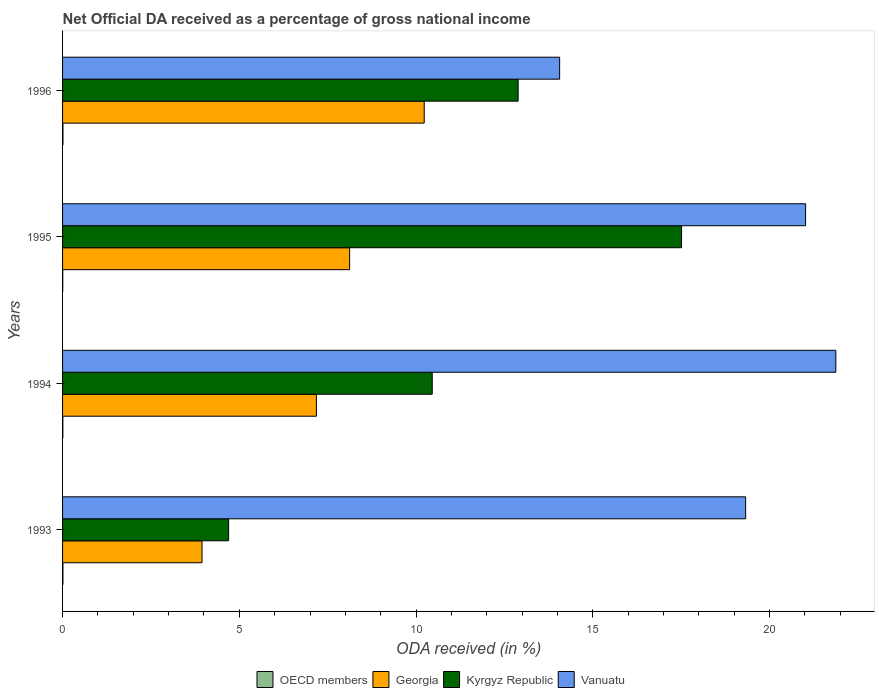How many different coloured bars are there?
Your answer should be very brief. 4. How many bars are there on the 2nd tick from the top?
Keep it short and to the point. 4. How many bars are there on the 1st tick from the bottom?
Provide a succinct answer. 4. What is the net official DA received in Vanuatu in 1995?
Your answer should be very brief. 21.02. Across all years, what is the maximum net official DA received in Kyrgyz Republic?
Provide a succinct answer. 17.51. Across all years, what is the minimum net official DA received in Kyrgyz Republic?
Offer a terse response. 4.7. What is the total net official DA received in Kyrgyz Republic in the graph?
Your answer should be very brief. 45.55. What is the difference between the net official DA received in Georgia in 1994 and that in 1996?
Your answer should be very brief. -3.05. What is the difference between the net official DA received in Kyrgyz Republic in 1993 and the net official DA received in Vanuatu in 1995?
Ensure brevity in your answer.  -16.32. What is the average net official DA received in OECD members per year?
Give a very brief answer. 0.01. In the year 1996, what is the difference between the net official DA received in Georgia and net official DA received in OECD members?
Ensure brevity in your answer.  10.22. What is the ratio of the net official DA received in OECD members in 1994 to that in 1996?
Your answer should be very brief. 0.74. Is the difference between the net official DA received in Georgia in 1993 and 1994 greater than the difference between the net official DA received in OECD members in 1993 and 1994?
Make the answer very short. No. What is the difference between the highest and the second highest net official DA received in Kyrgyz Republic?
Your response must be concise. 4.62. What is the difference between the highest and the lowest net official DA received in Georgia?
Ensure brevity in your answer.  6.29. In how many years, is the net official DA received in Kyrgyz Republic greater than the average net official DA received in Kyrgyz Republic taken over all years?
Make the answer very short. 2. Is the sum of the net official DA received in OECD members in 1993 and 1995 greater than the maximum net official DA received in Georgia across all years?
Provide a succinct answer. No. What does the 3rd bar from the bottom in 1996 represents?
Offer a very short reply. Kyrgyz Republic. Is it the case that in every year, the sum of the net official DA received in OECD members and net official DA received in Georgia is greater than the net official DA received in Kyrgyz Republic?
Provide a short and direct response. No. How many bars are there?
Offer a very short reply. 16. Are the values on the major ticks of X-axis written in scientific E-notation?
Give a very brief answer. No. Does the graph contain any zero values?
Your answer should be very brief. No. Where does the legend appear in the graph?
Ensure brevity in your answer.  Bottom center. What is the title of the graph?
Your answer should be very brief. Net Official DA received as a percentage of gross national income. Does "Latin America(all income levels)" appear as one of the legend labels in the graph?
Give a very brief answer. No. What is the label or title of the X-axis?
Provide a short and direct response. ODA received (in %). What is the ODA received (in %) of OECD members in 1993?
Ensure brevity in your answer.  0.01. What is the ODA received (in %) in Georgia in 1993?
Your answer should be very brief. 3.95. What is the ODA received (in %) in Kyrgyz Republic in 1993?
Give a very brief answer. 4.7. What is the ODA received (in %) of Vanuatu in 1993?
Offer a terse response. 19.32. What is the ODA received (in %) of OECD members in 1994?
Ensure brevity in your answer.  0.01. What is the ODA received (in %) in Georgia in 1994?
Your response must be concise. 7.18. What is the ODA received (in %) in Kyrgyz Republic in 1994?
Make the answer very short. 10.46. What is the ODA received (in %) of Vanuatu in 1994?
Ensure brevity in your answer.  21.88. What is the ODA received (in %) in OECD members in 1995?
Ensure brevity in your answer.  0.01. What is the ODA received (in %) of Georgia in 1995?
Provide a succinct answer. 8.12. What is the ODA received (in %) in Kyrgyz Republic in 1995?
Make the answer very short. 17.51. What is the ODA received (in %) of Vanuatu in 1995?
Give a very brief answer. 21.02. What is the ODA received (in %) of OECD members in 1996?
Your answer should be compact. 0.01. What is the ODA received (in %) in Georgia in 1996?
Your answer should be compact. 10.23. What is the ODA received (in %) in Kyrgyz Republic in 1996?
Offer a terse response. 12.89. What is the ODA received (in %) of Vanuatu in 1996?
Make the answer very short. 14.06. Across all years, what is the maximum ODA received (in %) of OECD members?
Provide a short and direct response. 0.01. Across all years, what is the maximum ODA received (in %) in Georgia?
Provide a succinct answer. 10.23. Across all years, what is the maximum ODA received (in %) of Kyrgyz Republic?
Your answer should be very brief. 17.51. Across all years, what is the maximum ODA received (in %) of Vanuatu?
Your answer should be compact. 21.88. Across all years, what is the minimum ODA received (in %) in OECD members?
Your answer should be compact. 0.01. Across all years, what is the minimum ODA received (in %) in Georgia?
Offer a very short reply. 3.95. Across all years, what is the minimum ODA received (in %) in Kyrgyz Republic?
Ensure brevity in your answer.  4.7. Across all years, what is the minimum ODA received (in %) in Vanuatu?
Your answer should be very brief. 14.06. What is the total ODA received (in %) of OECD members in the graph?
Offer a terse response. 0.04. What is the total ODA received (in %) of Georgia in the graph?
Your answer should be very brief. 29.48. What is the total ODA received (in %) of Kyrgyz Republic in the graph?
Your response must be concise. 45.55. What is the total ODA received (in %) of Vanuatu in the graph?
Your answer should be very brief. 76.28. What is the difference between the ODA received (in %) in OECD members in 1993 and that in 1994?
Offer a terse response. 0. What is the difference between the ODA received (in %) of Georgia in 1993 and that in 1994?
Give a very brief answer. -3.24. What is the difference between the ODA received (in %) in Kyrgyz Republic in 1993 and that in 1994?
Provide a succinct answer. -5.76. What is the difference between the ODA received (in %) of Vanuatu in 1993 and that in 1994?
Your response must be concise. -2.55. What is the difference between the ODA received (in %) of OECD members in 1993 and that in 1995?
Your answer should be compact. 0.01. What is the difference between the ODA received (in %) of Georgia in 1993 and that in 1995?
Ensure brevity in your answer.  -4.18. What is the difference between the ODA received (in %) in Kyrgyz Republic in 1993 and that in 1995?
Your answer should be compact. -12.81. What is the difference between the ODA received (in %) of Vanuatu in 1993 and that in 1995?
Give a very brief answer. -1.7. What is the difference between the ODA received (in %) in OECD members in 1993 and that in 1996?
Keep it short and to the point. -0. What is the difference between the ODA received (in %) of Georgia in 1993 and that in 1996?
Give a very brief answer. -6.29. What is the difference between the ODA received (in %) in Kyrgyz Republic in 1993 and that in 1996?
Your answer should be compact. -8.19. What is the difference between the ODA received (in %) in Vanuatu in 1993 and that in 1996?
Your response must be concise. 5.26. What is the difference between the ODA received (in %) of OECD members in 1994 and that in 1995?
Your response must be concise. 0. What is the difference between the ODA received (in %) of Georgia in 1994 and that in 1995?
Give a very brief answer. -0.94. What is the difference between the ODA received (in %) of Kyrgyz Republic in 1994 and that in 1995?
Your answer should be compact. -7.05. What is the difference between the ODA received (in %) in Vanuatu in 1994 and that in 1995?
Give a very brief answer. 0.86. What is the difference between the ODA received (in %) of OECD members in 1994 and that in 1996?
Make the answer very short. -0. What is the difference between the ODA received (in %) of Georgia in 1994 and that in 1996?
Provide a short and direct response. -3.05. What is the difference between the ODA received (in %) of Kyrgyz Republic in 1994 and that in 1996?
Your answer should be compact. -2.43. What is the difference between the ODA received (in %) in Vanuatu in 1994 and that in 1996?
Your response must be concise. 7.81. What is the difference between the ODA received (in %) in OECD members in 1995 and that in 1996?
Make the answer very short. -0.01. What is the difference between the ODA received (in %) of Georgia in 1995 and that in 1996?
Provide a short and direct response. -2.11. What is the difference between the ODA received (in %) in Kyrgyz Republic in 1995 and that in 1996?
Offer a terse response. 4.62. What is the difference between the ODA received (in %) in Vanuatu in 1995 and that in 1996?
Offer a terse response. 6.96. What is the difference between the ODA received (in %) of OECD members in 1993 and the ODA received (in %) of Georgia in 1994?
Offer a terse response. -7.17. What is the difference between the ODA received (in %) of OECD members in 1993 and the ODA received (in %) of Kyrgyz Republic in 1994?
Make the answer very short. -10.45. What is the difference between the ODA received (in %) of OECD members in 1993 and the ODA received (in %) of Vanuatu in 1994?
Ensure brevity in your answer.  -21.87. What is the difference between the ODA received (in %) in Georgia in 1993 and the ODA received (in %) in Kyrgyz Republic in 1994?
Keep it short and to the point. -6.51. What is the difference between the ODA received (in %) of Georgia in 1993 and the ODA received (in %) of Vanuatu in 1994?
Ensure brevity in your answer.  -17.93. What is the difference between the ODA received (in %) of Kyrgyz Republic in 1993 and the ODA received (in %) of Vanuatu in 1994?
Make the answer very short. -17.18. What is the difference between the ODA received (in %) in OECD members in 1993 and the ODA received (in %) in Georgia in 1995?
Provide a short and direct response. -8.11. What is the difference between the ODA received (in %) of OECD members in 1993 and the ODA received (in %) of Kyrgyz Republic in 1995?
Provide a succinct answer. -17.5. What is the difference between the ODA received (in %) of OECD members in 1993 and the ODA received (in %) of Vanuatu in 1995?
Provide a succinct answer. -21.01. What is the difference between the ODA received (in %) of Georgia in 1993 and the ODA received (in %) of Kyrgyz Republic in 1995?
Ensure brevity in your answer.  -13.57. What is the difference between the ODA received (in %) of Georgia in 1993 and the ODA received (in %) of Vanuatu in 1995?
Your answer should be very brief. -17.07. What is the difference between the ODA received (in %) of Kyrgyz Republic in 1993 and the ODA received (in %) of Vanuatu in 1995?
Offer a terse response. -16.32. What is the difference between the ODA received (in %) in OECD members in 1993 and the ODA received (in %) in Georgia in 1996?
Your answer should be very brief. -10.22. What is the difference between the ODA received (in %) in OECD members in 1993 and the ODA received (in %) in Kyrgyz Republic in 1996?
Your answer should be compact. -12.88. What is the difference between the ODA received (in %) in OECD members in 1993 and the ODA received (in %) in Vanuatu in 1996?
Offer a terse response. -14.05. What is the difference between the ODA received (in %) of Georgia in 1993 and the ODA received (in %) of Kyrgyz Republic in 1996?
Make the answer very short. -8.94. What is the difference between the ODA received (in %) in Georgia in 1993 and the ODA received (in %) in Vanuatu in 1996?
Offer a terse response. -10.12. What is the difference between the ODA received (in %) of Kyrgyz Republic in 1993 and the ODA received (in %) of Vanuatu in 1996?
Offer a very short reply. -9.36. What is the difference between the ODA received (in %) in OECD members in 1994 and the ODA received (in %) in Georgia in 1995?
Ensure brevity in your answer.  -8.11. What is the difference between the ODA received (in %) in OECD members in 1994 and the ODA received (in %) in Kyrgyz Republic in 1995?
Your response must be concise. -17.5. What is the difference between the ODA received (in %) in OECD members in 1994 and the ODA received (in %) in Vanuatu in 1995?
Make the answer very short. -21.01. What is the difference between the ODA received (in %) in Georgia in 1994 and the ODA received (in %) in Kyrgyz Republic in 1995?
Offer a very short reply. -10.33. What is the difference between the ODA received (in %) in Georgia in 1994 and the ODA received (in %) in Vanuatu in 1995?
Make the answer very short. -13.84. What is the difference between the ODA received (in %) in Kyrgyz Republic in 1994 and the ODA received (in %) in Vanuatu in 1995?
Offer a very short reply. -10.56. What is the difference between the ODA received (in %) of OECD members in 1994 and the ODA received (in %) of Georgia in 1996?
Make the answer very short. -10.22. What is the difference between the ODA received (in %) of OECD members in 1994 and the ODA received (in %) of Kyrgyz Republic in 1996?
Keep it short and to the point. -12.88. What is the difference between the ODA received (in %) of OECD members in 1994 and the ODA received (in %) of Vanuatu in 1996?
Provide a short and direct response. -14.05. What is the difference between the ODA received (in %) of Georgia in 1994 and the ODA received (in %) of Kyrgyz Republic in 1996?
Provide a short and direct response. -5.71. What is the difference between the ODA received (in %) of Georgia in 1994 and the ODA received (in %) of Vanuatu in 1996?
Make the answer very short. -6.88. What is the difference between the ODA received (in %) of Kyrgyz Republic in 1994 and the ODA received (in %) of Vanuatu in 1996?
Offer a very short reply. -3.6. What is the difference between the ODA received (in %) in OECD members in 1995 and the ODA received (in %) in Georgia in 1996?
Offer a terse response. -10.23. What is the difference between the ODA received (in %) in OECD members in 1995 and the ODA received (in %) in Kyrgyz Republic in 1996?
Provide a succinct answer. -12.88. What is the difference between the ODA received (in %) in OECD members in 1995 and the ODA received (in %) in Vanuatu in 1996?
Your response must be concise. -14.06. What is the difference between the ODA received (in %) in Georgia in 1995 and the ODA received (in %) in Kyrgyz Republic in 1996?
Your answer should be compact. -4.77. What is the difference between the ODA received (in %) in Georgia in 1995 and the ODA received (in %) in Vanuatu in 1996?
Offer a very short reply. -5.94. What is the difference between the ODA received (in %) of Kyrgyz Republic in 1995 and the ODA received (in %) of Vanuatu in 1996?
Provide a succinct answer. 3.45. What is the average ODA received (in %) in OECD members per year?
Provide a short and direct response. 0.01. What is the average ODA received (in %) of Georgia per year?
Give a very brief answer. 7.37. What is the average ODA received (in %) of Kyrgyz Republic per year?
Offer a very short reply. 11.39. What is the average ODA received (in %) of Vanuatu per year?
Your response must be concise. 19.07. In the year 1993, what is the difference between the ODA received (in %) in OECD members and ODA received (in %) in Georgia?
Provide a succinct answer. -3.94. In the year 1993, what is the difference between the ODA received (in %) of OECD members and ODA received (in %) of Kyrgyz Republic?
Keep it short and to the point. -4.69. In the year 1993, what is the difference between the ODA received (in %) in OECD members and ODA received (in %) in Vanuatu?
Your answer should be compact. -19.31. In the year 1993, what is the difference between the ODA received (in %) of Georgia and ODA received (in %) of Kyrgyz Republic?
Your answer should be very brief. -0.75. In the year 1993, what is the difference between the ODA received (in %) of Georgia and ODA received (in %) of Vanuatu?
Your answer should be very brief. -15.38. In the year 1993, what is the difference between the ODA received (in %) of Kyrgyz Republic and ODA received (in %) of Vanuatu?
Offer a terse response. -14.63. In the year 1994, what is the difference between the ODA received (in %) in OECD members and ODA received (in %) in Georgia?
Give a very brief answer. -7.17. In the year 1994, what is the difference between the ODA received (in %) in OECD members and ODA received (in %) in Kyrgyz Republic?
Make the answer very short. -10.45. In the year 1994, what is the difference between the ODA received (in %) of OECD members and ODA received (in %) of Vanuatu?
Offer a terse response. -21.87. In the year 1994, what is the difference between the ODA received (in %) of Georgia and ODA received (in %) of Kyrgyz Republic?
Provide a short and direct response. -3.28. In the year 1994, what is the difference between the ODA received (in %) in Georgia and ODA received (in %) in Vanuatu?
Provide a succinct answer. -14.69. In the year 1994, what is the difference between the ODA received (in %) of Kyrgyz Republic and ODA received (in %) of Vanuatu?
Give a very brief answer. -11.42. In the year 1995, what is the difference between the ODA received (in %) in OECD members and ODA received (in %) in Georgia?
Your answer should be very brief. -8.12. In the year 1995, what is the difference between the ODA received (in %) in OECD members and ODA received (in %) in Kyrgyz Republic?
Provide a succinct answer. -17.51. In the year 1995, what is the difference between the ODA received (in %) of OECD members and ODA received (in %) of Vanuatu?
Ensure brevity in your answer.  -21.02. In the year 1995, what is the difference between the ODA received (in %) of Georgia and ODA received (in %) of Kyrgyz Republic?
Offer a terse response. -9.39. In the year 1995, what is the difference between the ODA received (in %) of Georgia and ODA received (in %) of Vanuatu?
Provide a succinct answer. -12.9. In the year 1995, what is the difference between the ODA received (in %) of Kyrgyz Republic and ODA received (in %) of Vanuatu?
Provide a succinct answer. -3.51. In the year 1996, what is the difference between the ODA received (in %) in OECD members and ODA received (in %) in Georgia?
Ensure brevity in your answer.  -10.22. In the year 1996, what is the difference between the ODA received (in %) in OECD members and ODA received (in %) in Kyrgyz Republic?
Give a very brief answer. -12.88. In the year 1996, what is the difference between the ODA received (in %) in OECD members and ODA received (in %) in Vanuatu?
Offer a very short reply. -14.05. In the year 1996, what is the difference between the ODA received (in %) in Georgia and ODA received (in %) in Kyrgyz Republic?
Provide a short and direct response. -2.66. In the year 1996, what is the difference between the ODA received (in %) of Georgia and ODA received (in %) of Vanuatu?
Offer a very short reply. -3.83. In the year 1996, what is the difference between the ODA received (in %) in Kyrgyz Republic and ODA received (in %) in Vanuatu?
Your answer should be compact. -1.17. What is the ratio of the ODA received (in %) of OECD members in 1993 to that in 1994?
Your answer should be compact. 1.26. What is the ratio of the ODA received (in %) in Georgia in 1993 to that in 1994?
Your answer should be very brief. 0.55. What is the ratio of the ODA received (in %) of Kyrgyz Republic in 1993 to that in 1994?
Keep it short and to the point. 0.45. What is the ratio of the ODA received (in %) of Vanuatu in 1993 to that in 1994?
Give a very brief answer. 0.88. What is the ratio of the ODA received (in %) of OECD members in 1993 to that in 1995?
Provide a short and direct response. 2.06. What is the ratio of the ODA received (in %) of Georgia in 1993 to that in 1995?
Ensure brevity in your answer.  0.49. What is the ratio of the ODA received (in %) of Kyrgyz Republic in 1993 to that in 1995?
Your answer should be very brief. 0.27. What is the ratio of the ODA received (in %) of Vanuatu in 1993 to that in 1995?
Provide a succinct answer. 0.92. What is the ratio of the ODA received (in %) of OECD members in 1993 to that in 1996?
Your response must be concise. 0.94. What is the ratio of the ODA received (in %) of Georgia in 1993 to that in 1996?
Give a very brief answer. 0.39. What is the ratio of the ODA received (in %) of Kyrgyz Republic in 1993 to that in 1996?
Your answer should be compact. 0.36. What is the ratio of the ODA received (in %) of Vanuatu in 1993 to that in 1996?
Your response must be concise. 1.37. What is the ratio of the ODA received (in %) of OECD members in 1994 to that in 1995?
Offer a terse response. 1.63. What is the ratio of the ODA received (in %) in Georgia in 1994 to that in 1995?
Provide a succinct answer. 0.88. What is the ratio of the ODA received (in %) in Kyrgyz Republic in 1994 to that in 1995?
Your answer should be very brief. 0.6. What is the ratio of the ODA received (in %) in Vanuatu in 1994 to that in 1995?
Offer a terse response. 1.04. What is the ratio of the ODA received (in %) in OECD members in 1994 to that in 1996?
Give a very brief answer. 0.74. What is the ratio of the ODA received (in %) of Georgia in 1994 to that in 1996?
Give a very brief answer. 0.7. What is the ratio of the ODA received (in %) in Kyrgyz Republic in 1994 to that in 1996?
Your response must be concise. 0.81. What is the ratio of the ODA received (in %) of Vanuatu in 1994 to that in 1996?
Your answer should be very brief. 1.56. What is the ratio of the ODA received (in %) in OECD members in 1995 to that in 1996?
Your response must be concise. 0.46. What is the ratio of the ODA received (in %) of Georgia in 1995 to that in 1996?
Offer a very short reply. 0.79. What is the ratio of the ODA received (in %) of Kyrgyz Republic in 1995 to that in 1996?
Your answer should be very brief. 1.36. What is the ratio of the ODA received (in %) in Vanuatu in 1995 to that in 1996?
Offer a terse response. 1.49. What is the difference between the highest and the second highest ODA received (in %) of OECD members?
Make the answer very short. 0. What is the difference between the highest and the second highest ODA received (in %) in Georgia?
Make the answer very short. 2.11. What is the difference between the highest and the second highest ODA received (in %) of Kyrgyz Republic?
Provide a short and direct response. 4.62. What is the difference between the highest and the second highest ODA received (in %) of Vanuatu?
Give a very brief answer. 0.86. What is the difference between the highest and the lowest ODA received (in %) in OECD members?
Offer a very short reply. 0.01. What is the difference between the highest and the lowest ODA received (in %) in Georgia?
Offer a very short reply. 6.29. What is the difference between the highest and the lowest ODA received (in %) in Kyrgyz Republic?
Your response must be concise. 12.81. What is the difference between the highest and the lowest ODA received (in %) in Vanuatu?
Your answer should be very brief. 7.81. 